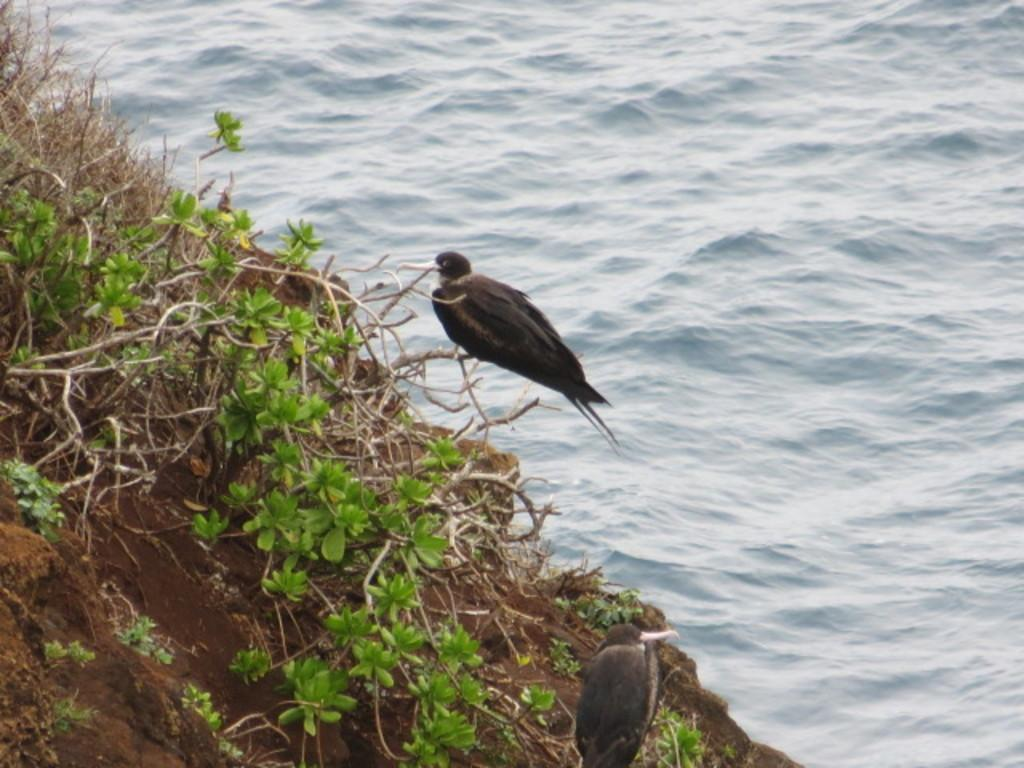How many birds are present in the image? There are two birds in the image. What color are the birds? The birds are black in color. Where are the birds located in the image? The birds are on the stems of plants. What other elements can be seen in the image? There is mud and water in the image. What type of bulb is being used to provide approval for the loss in the image? There is no bulb, approval, or loss mentioned or depicted in the image. 